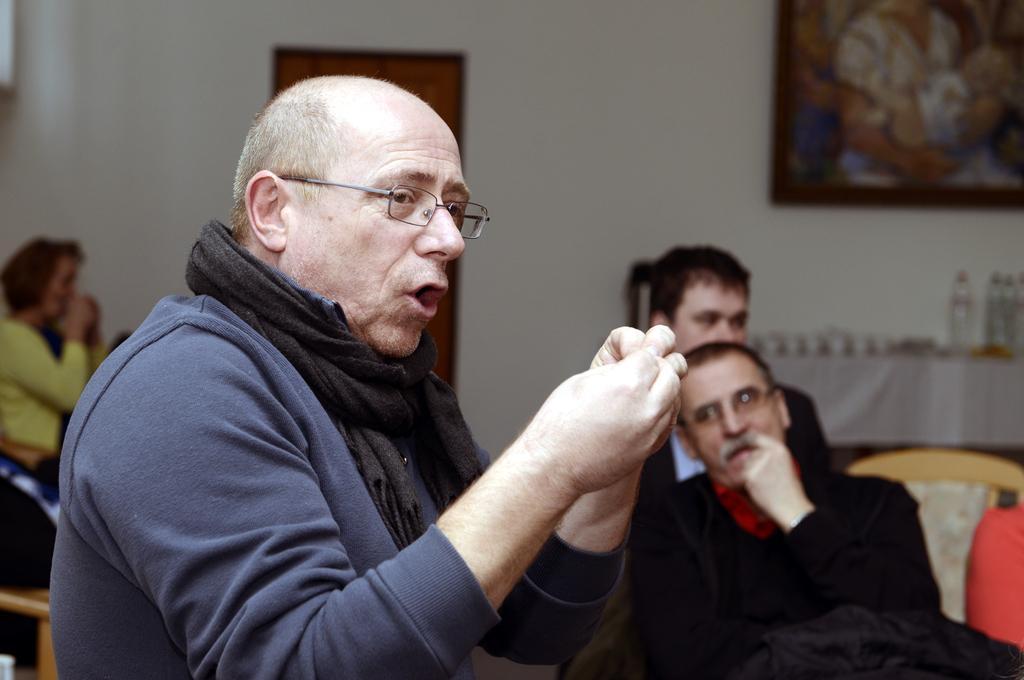Can you describe this image briefly? In this image I can see a person is wearing blue and black dress. Back I can see few people sitting. The frame is attached to the wall. 